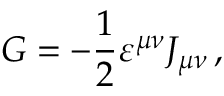Convert formula to latex. <formula><loc_0><loc_0><loc_500><loc_500>G = - \frac { 1 } { 2 } \varepsilon ^ { \mu \nu } J _ { \mu \nu } \, ,</formula> 